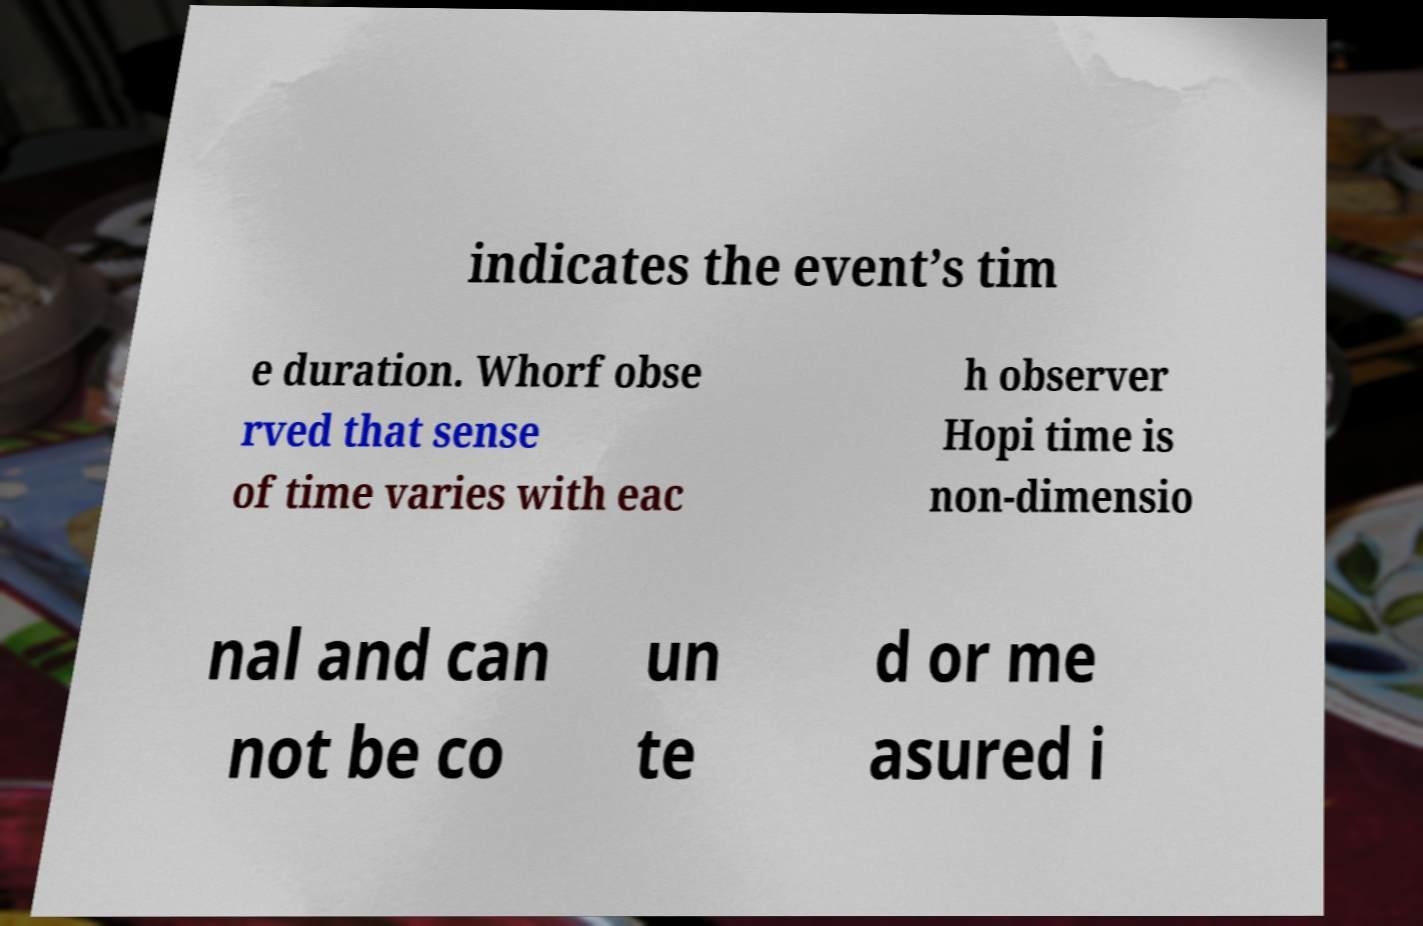Please read and relay the text visible in this image. What does it say? indicates the event’s tim e duration. Whorf obse rved that sense of time varies with eac h observer Hopi time is non-dimensio nal and can not be co un te d or me asured i 